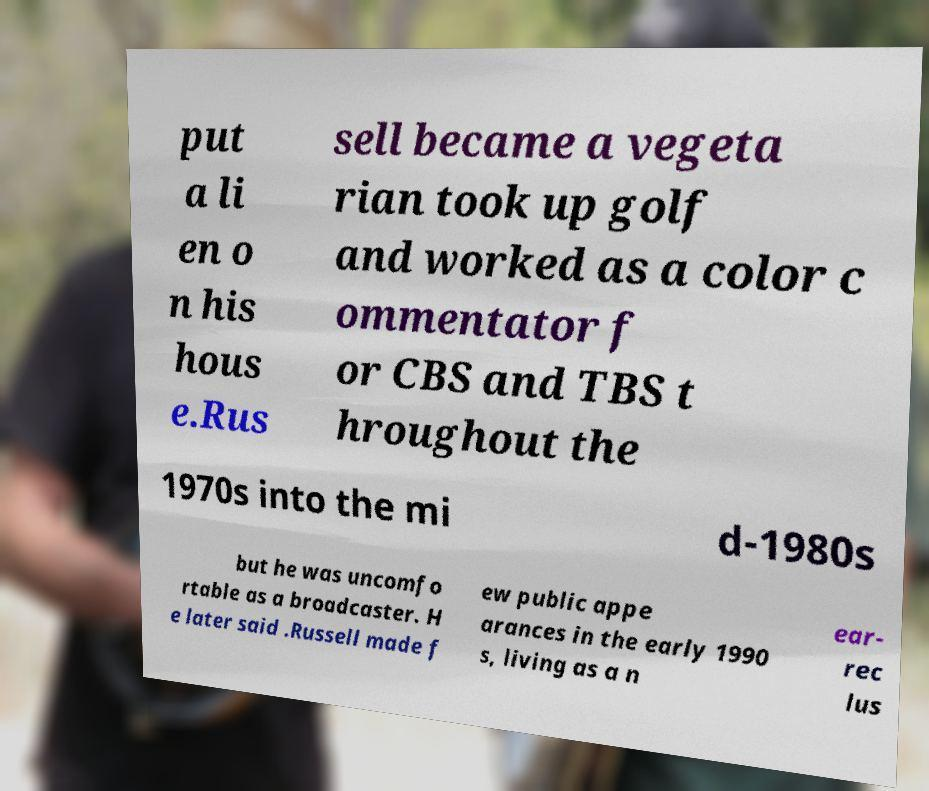What messages or text are displayed in this image? I need them in a readable, typed format. put a li en o n his hous e.Rus sell became a vegeta rian took up golf and worked as a color c ommentator f or CBS and TBS t hroughout the 1970s into the mi d-1980s but he was uncomfo rtable as a broadcaster. H e later said .Russell made f ew public appe arances in the early 1990 s, living as a n ear- rec lus 